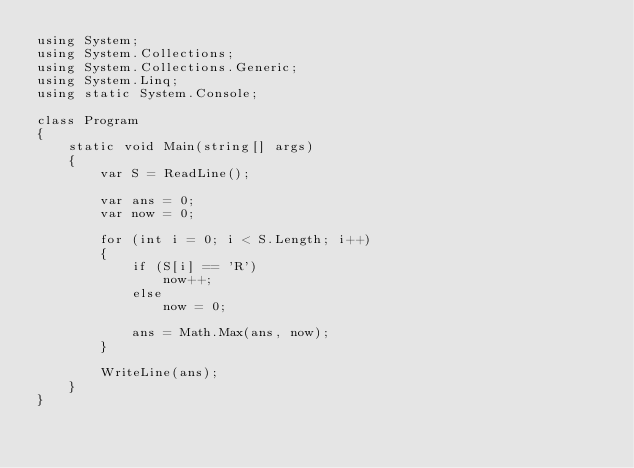<code> <loc_0><loc_0><loc_500><loc_500><_C#_>using System;
using System.Collections;
using System.Collections.Generic;
using System.Linq;
using static System.Console;

class Program
{
    static void Main(string[] args)
    {
        var S = ReadLine();

        var ans = 0;
        var now = 0;

        for (int i = 0; i < S.Length; i++)
        {
            if (S[i] == 'R')
                now++;
            else
                now = 0;

            ans = Math.Max(ans, now);
        }

        WriteLine(ans);
    }
}
</code> 